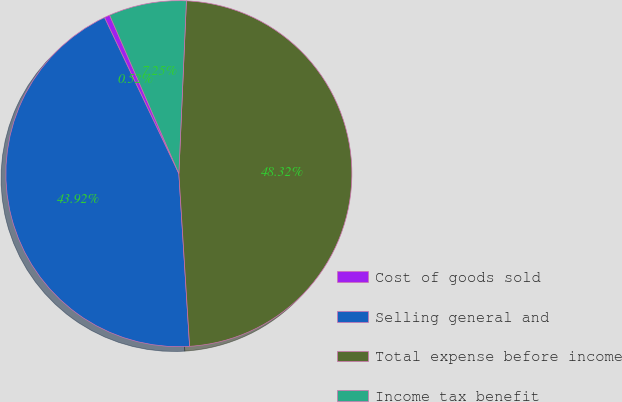Convert chart. <chart><loc_0><loc_0><loc_500><loc_500><pie_chart><fcel>Cost of goods sold<fcel>Selling general and<fcel>Total expense before income<fcel>Income tax benefit<nl><fcel>0.52%<fcel>43.92%<fcel>48.32%<fcel>7.25%<nl></chart> 